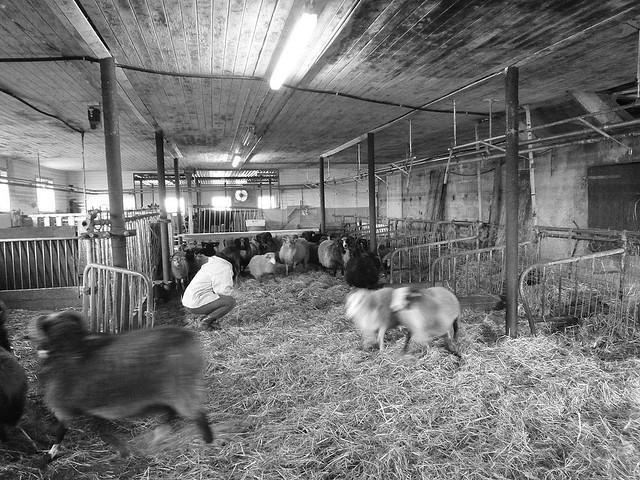How many sheep are there?
Give a very brief answer. 3. How many yellow buses are in the picture?
Give a very brief answer. 0. 